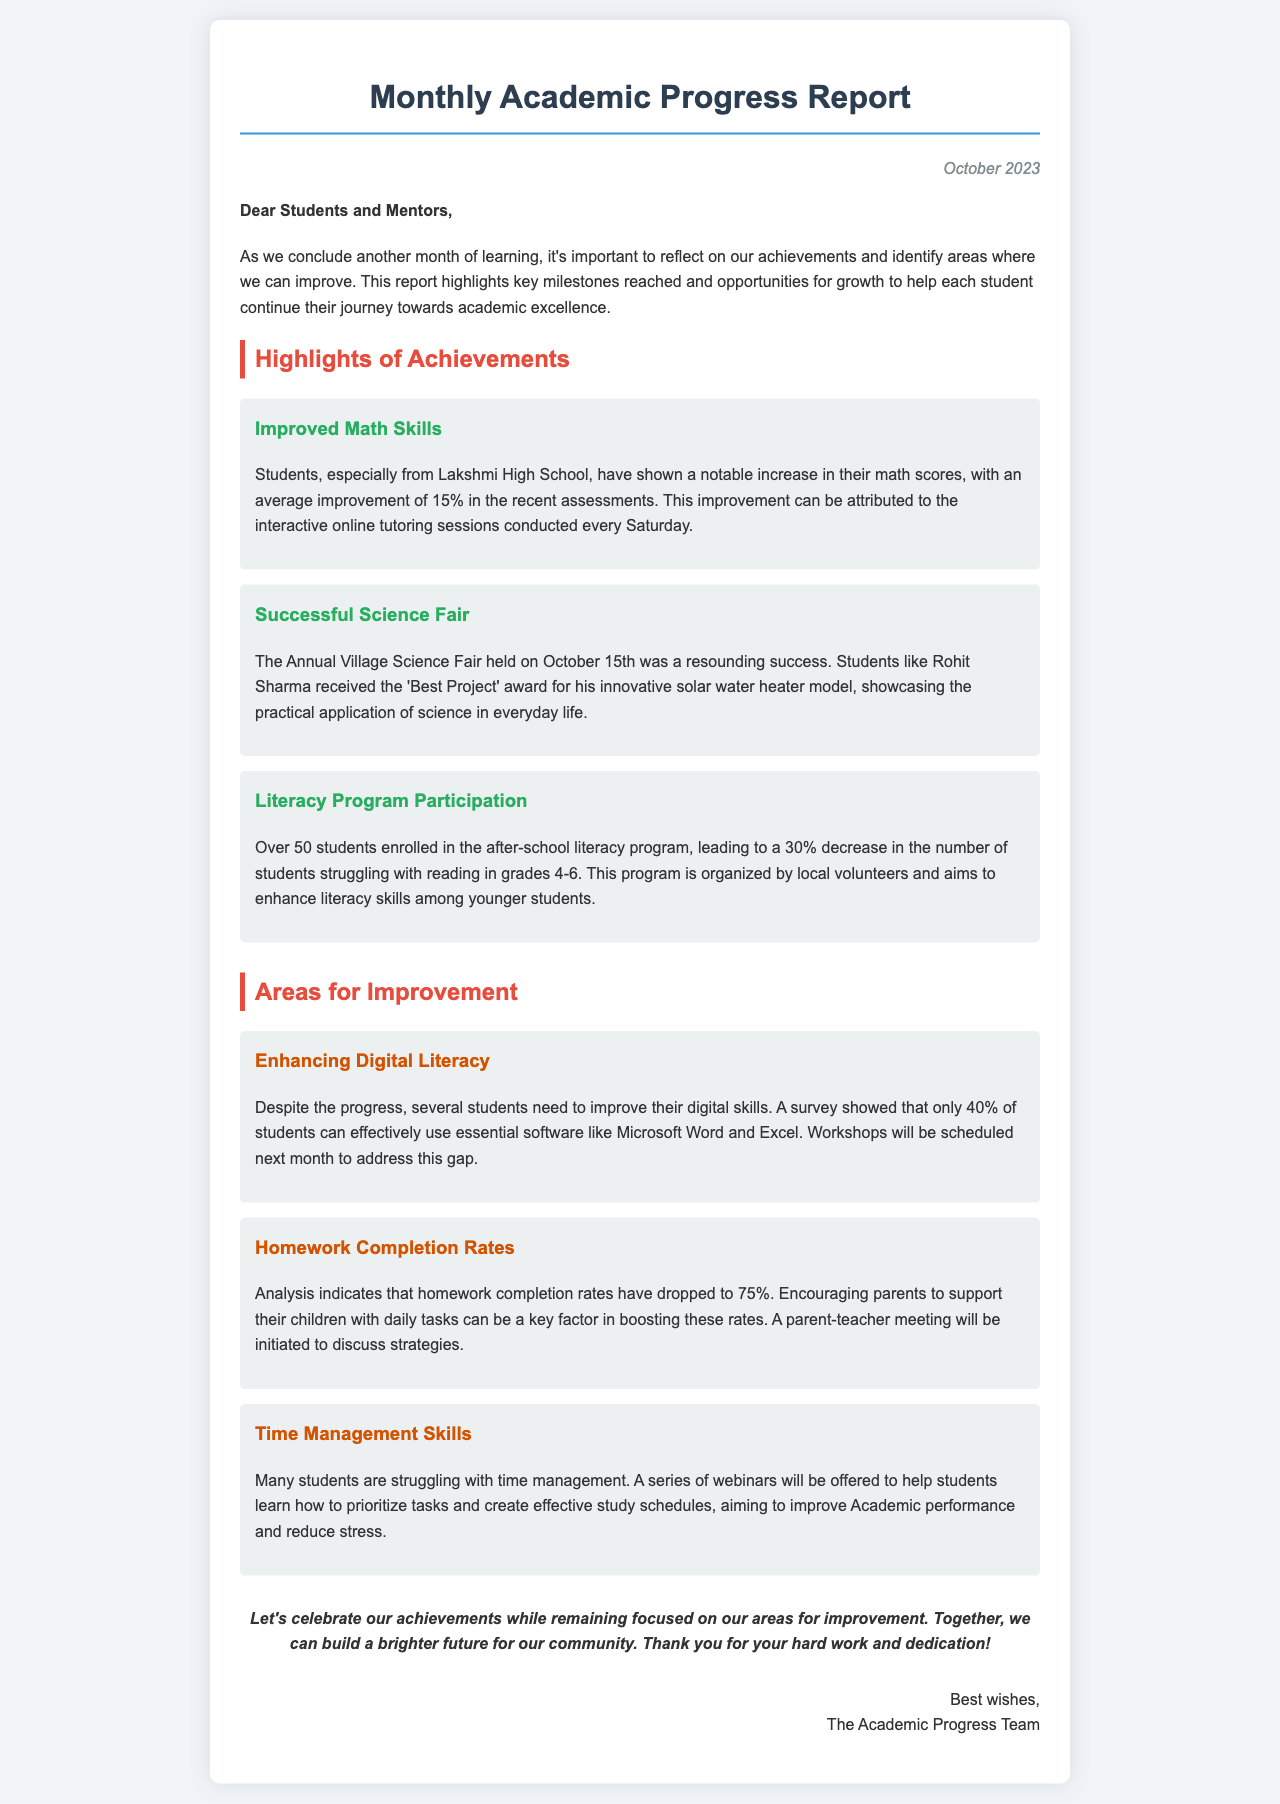What was the average improvement in math scores? The average improvement in math scores is stated as 15% in the recent assessments.
Answer: 15% Who received the 'Best Project' award at the Science Fair? The 'Best Project' award was received by Rohit Sharma for his innovative solar water heater model.
Answer: Rohit Sharma What percentage of students can effectively use software like Microsoft Word and Excel? According to the survey, only 40% of students can effectively use essential software.
Answer: 40% What is the current homework completion rate? The report indicates that the homework completion rates have dropped to 75%.
Answer: 75% When was the Annual Village Science Fair held? The Annual Village Science Fair was held on October 15th.
Answer: October 15th What is the aim of the after-school literacy program? The aim of the after-school literacy program is to enhance literacy skills among younger students.
Answer: Enhance literacy skills What will be scheduled next month to address digital skills? Workshops will be scheduled next month to improve digital skills among students.
Answer: Workshops What issue is related to time management skills? Students are struggling with time management, prompting a series of webinars to be offered.
Answer: Time management skills What is one strategy to improve homework completion rates? Encouraging parents to support their children with daily tasks can help boost homework completion rates.
Answer: Parental support 